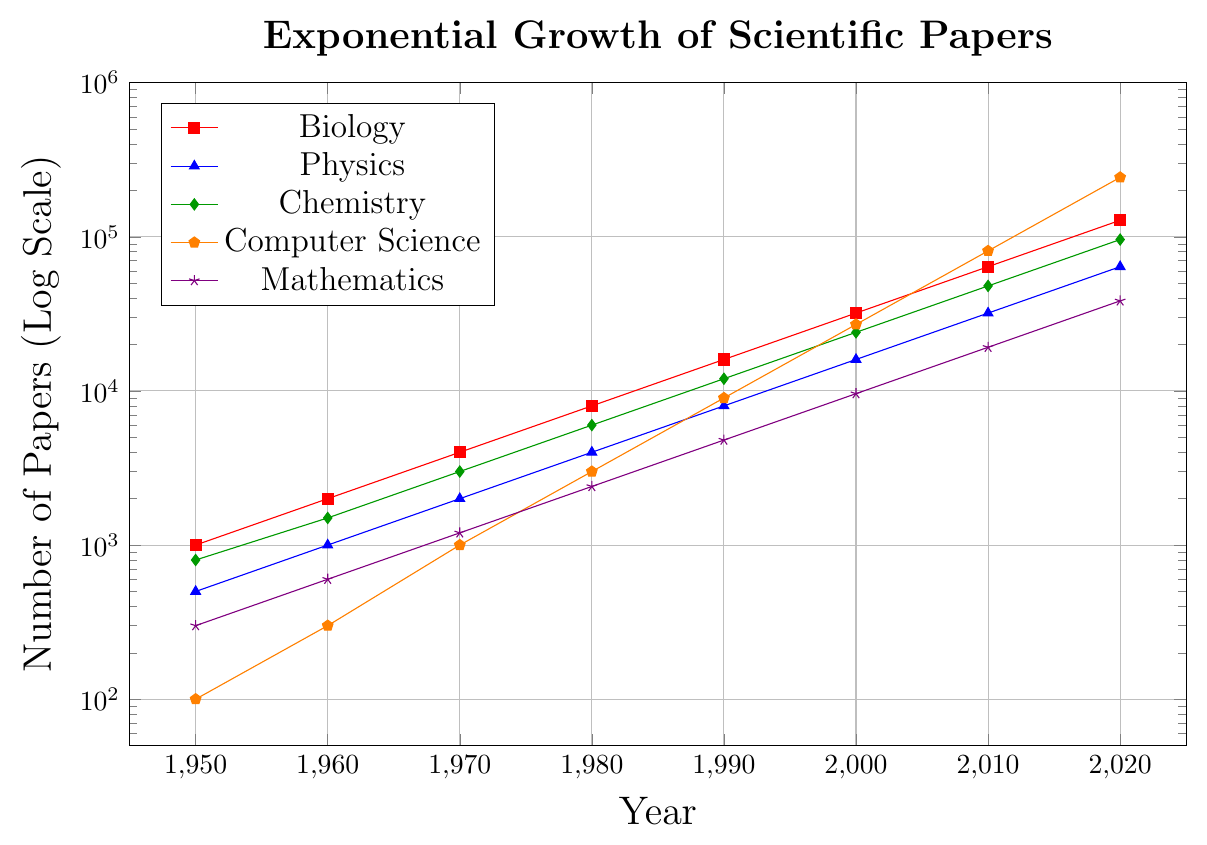Which academic field has the most published scientific papers in 2020? By referring to the figure, we can observe the endpoints of all plotted lines in 2020. The line representing Computer Science reaches the highest value, indicating it has the most published papers.
Answer: Computer Science How many academic fields published at least 10,000 papers in 2000? We look at the values in 2000 along the vertical axis for each academic field. Biology, Physics, Chemistry, and Computer Science all exceed 10,000 papers. Mathematics remains below this threshold. Counting these four fields gives the answer.
Answer: 4 During which decade did Mathematics see the most significant increase in the number of published papers? We need to compare values between decades (1950-1960, 1960-1970, etc.) for Mathematics, then identify the decade with the largest difference. The increase from 9000 in 1990 to 19200 in 2000 (more than doubling) is the most significant.
Answer: 1990-2000 Which two fields showed a similar trend in the rate of growth of published papers from 1950 to 2020? Observing the slopes of the plotted lines, Biology and Chemistry have similar upward trends, indicating a similar growth rate over the years.
Answer: Biology and Chemistry What is the overall trend observed in the number of published papers for all fields? We notice that all plotted lines show a continuously upward trend, reflecting that the number of published papers across all fields exhibits exponential growth.
Answer: Exponential growth By how much did the number of published papers in Chemistry increase from 1980 to 2010? Subtract the 1980 value from the 2010 value for Chemistry: 48000 - 6000 = 42000.
Answer: 42000 How many times higher was the number of published papers in Biology compared to Mathematics in 2020? Divide the number of papers in Biology by the number of papers in Mathematics in 2020: 128000 / 38400 = 3.33.
Answer: 3.33 times Which field’s publication growth rate outpaced others between 1990 and 2000? By finding the steepest slope between these years, Computer Science shows the steepest increase from 9000 to 27000.
Answer: Computer Science 